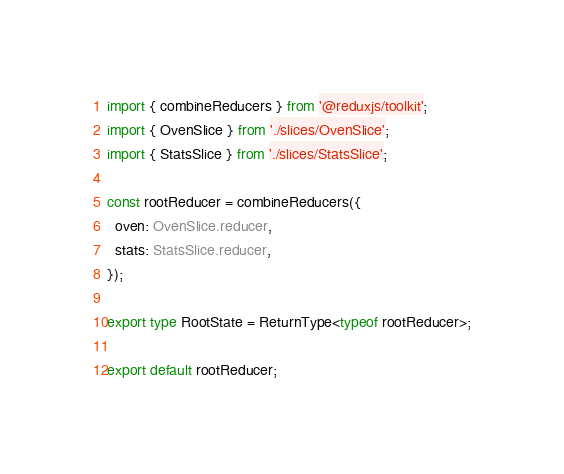Convert code to text. <code><loc_0><loc_0><loc_500><loc_500><_TypeScript_>import { combineReducers } from '@reduxjs/toolkit';
import { OvenSlice } from './slices/OvenSlice';
import { StatsSlice } from './slices/StatsSlice';

const rootReducer = combineReducers({
  oven: OvenSlice.reducer,
  stats: StatsSlice.reducer,
});

export type RootState = ReturnType<typeof rootReducer>;

export default rootReducer;
</code> 